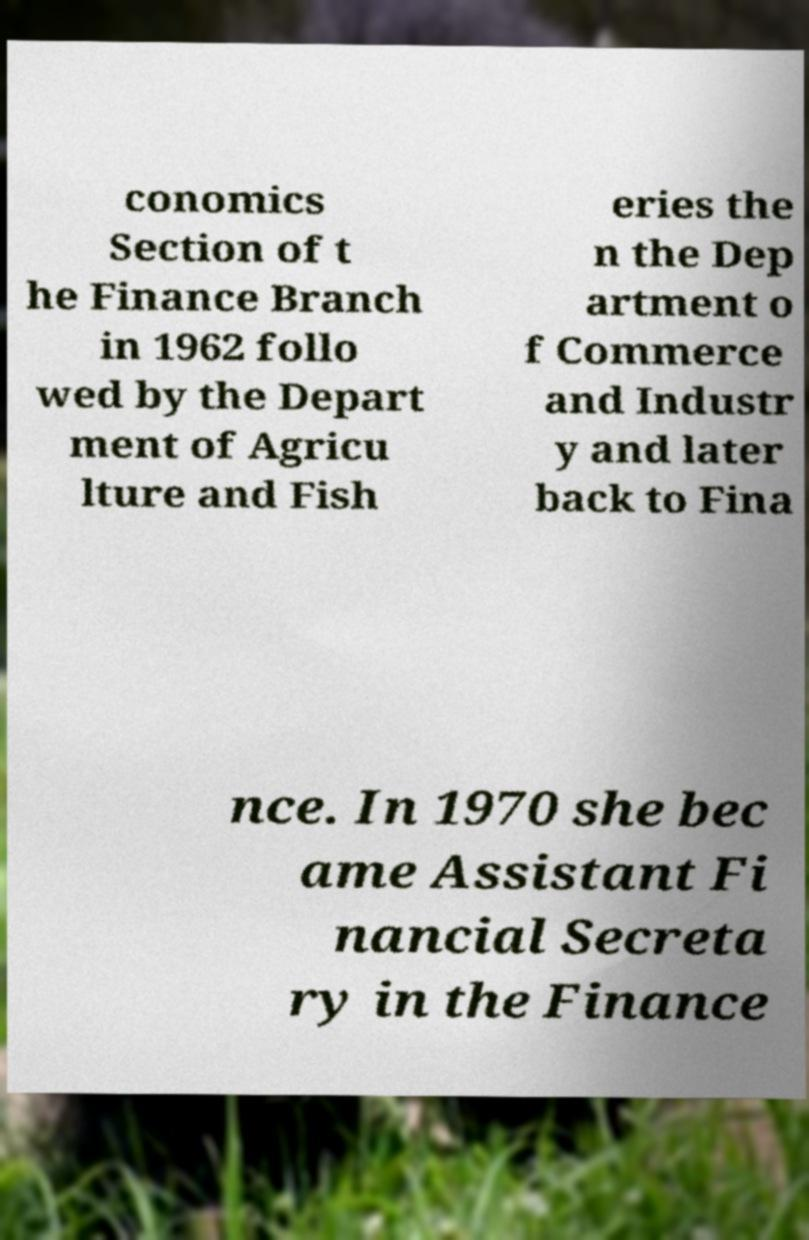Could you assist in decoding the text presented in this image and type it out clearly? conomics Section of t he Finance Branch in 1962 follo wed by the Depart ment of Agricu lture and Fish eries the n the Dep artment o f Commerce and Industr y and later back to Fina nce. In 1970 she bec ame Assistant Fi nancial Secreta ry in the Finance 